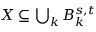Convert formula to latex. <formula><loc_0><loc_0><loc_500><loc_500>X \subseteq \bigcup _ { k } B _ { k } ^ { s , t }</formula> 